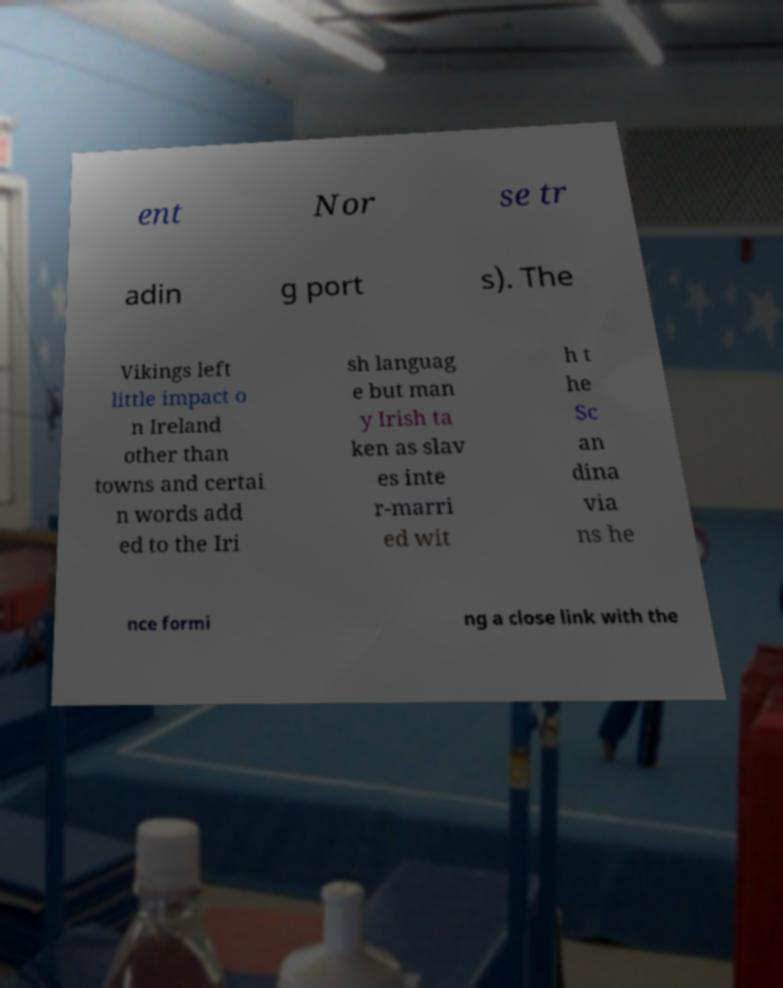Please read and relay the text visible in this image. What does it say? ent Nor se tr adin g port s). The Vikings left little impact o n Ireland other than towns and certai n words add ed to the Iri sh languag e but man y Irish ta ken as slav es inte r-marri ed wit h t he Sc an dina via ns he nce formi ng a close link with the 